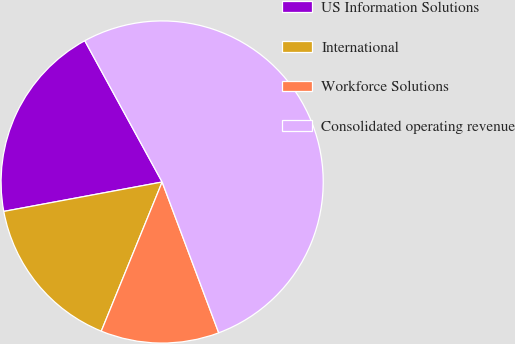Convert chart to OTSL. <chart><loc_0><loc_0><loc_500><loc_500><pie_chart><fcel>US Information Solutions<fcel>International<fcel>Workforce Solutions<fcel>Consolidated operating revenue<nl><fcel>19.95%<fcel>15.91%<fcel>11.88%<fcel>52.26%<nl></chart> 